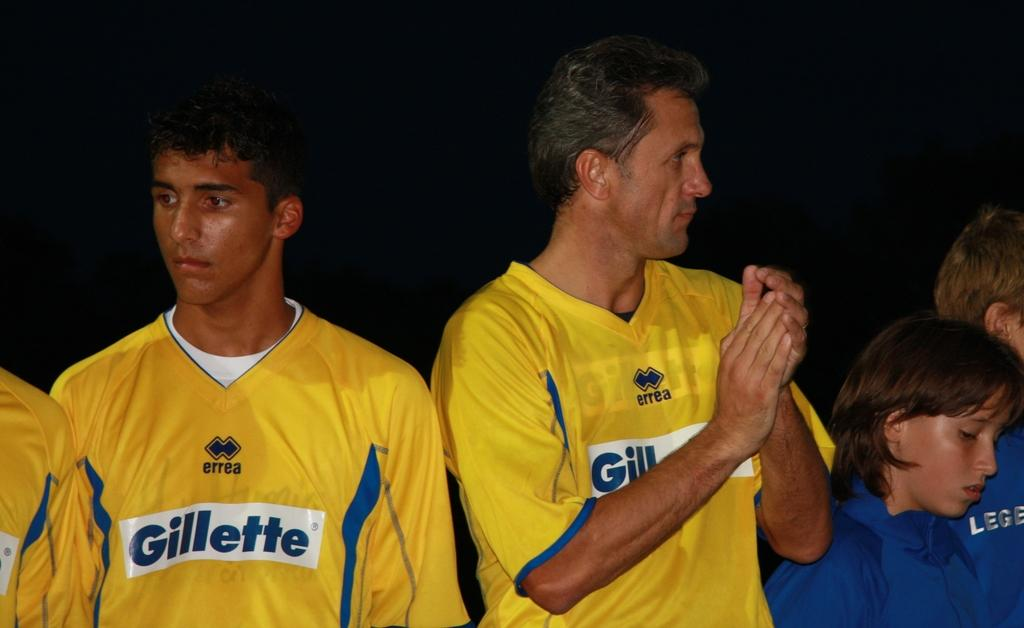<image>
Relay a brief, clear account of the picture shown. Men wearing Gillette sponsored jersey stand against a dark background 